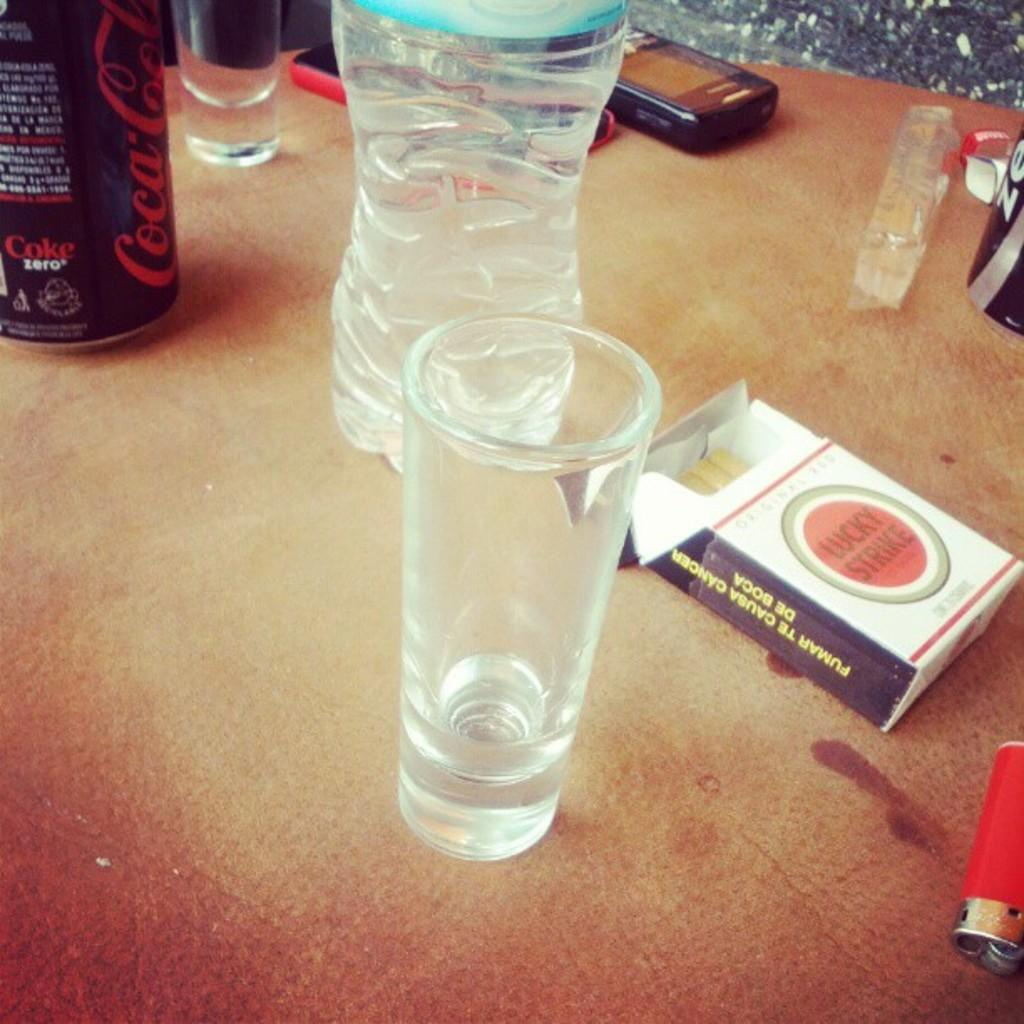<image>
Create a compact narrative representing the image presented. A table which includes a pack with three cigarettes of Lucky Strike with a red lighter next to it along with a Coke can and various other objects 